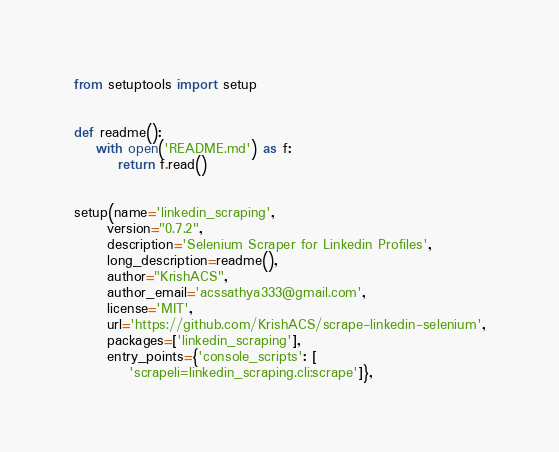Convert code to text. <code><loc_0><loc_0><loc_500><loc_500><_Python_>from setuptools import setup


def readme():
    with open('README.md') as f:
        return f.read()


setup(name='linkedin_scraping',
      version="0.7.2",
      description='Selenium Scraper for Linkedin Profiles',
      long_description=readme(),
      author="KrishACS",
      author_email='acssathya333@gmail.com',
      license='MIT',
      url='https://github.com/KrishACS/scrape-linkedin-selenium',
      packages=['linkedin_scraping'],
      entry_points={'console_scripts': [
          'scrapeli=linkedin_scraping.cli:scrape']},</code> 